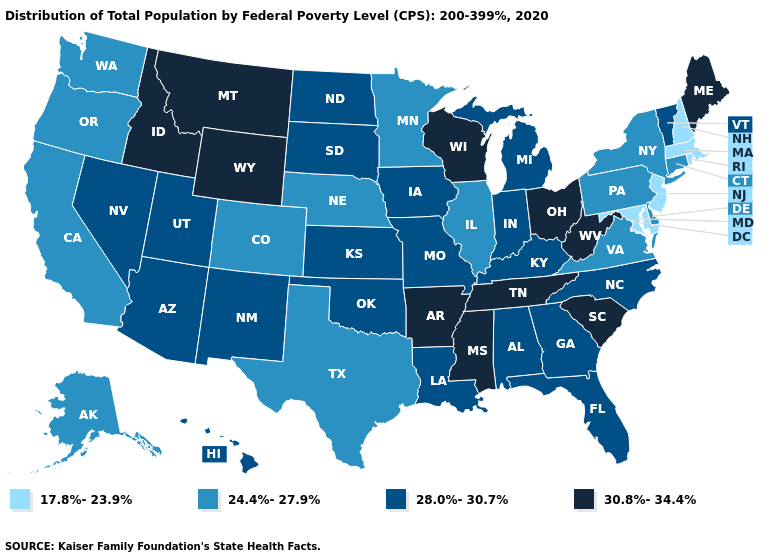Among the states that border Illinois , does Wisconsin have the highest value?
Be succinct. Yes. Does New Hampshire have the highest value in the USA?
Give a very brief answer. No. Among the states that border Oklahoma , which have the lowest value?
Short answer required. Colorado, Texas. What is the value of Virginia?
Quick response, please. 24.4%-27.9%. Name the states that have a value in the range 30.8%-34.4%?
Write a very short answer. Arkansas, Idaho, Maine, Mississippi, Montana, Ohio, South Carolina, Tennessee, West Virginia, Wisconsin, Wyoming. What is the value of Washington?
Keep it brief. 24.4%-27.9%. How many symbols are there in the legend?
Be succinct. 4. What is the value of South Dakota?
Write a very short answer. 28.0%-30.7%. What is the value of New Jersey?
Answer briefly. 17.8%-23.9%. Name the states that have a value in the range 17.8%-23.9%?
Keep it brief. Maryland, Massachusetts, New Hampshire, New Jersey, Rhode Island. Does New Hampshire have the lowest value in the USA?
Short answer required. Yes. Which states hav the highest value in the South?
Quick response, please. Arkansas, Mississippi, South Carolina, Tennessee, West Virginia. What is the value of North Carolina?
Short answer required. 28.0%-30.7%. What is the value of Rhode Island?
Concise answer only. 17.8%-23.9%. Among the states that border Minnesota , which have the lowest value?
Short answer required. Iowa, North Dakota, South Dakota. 